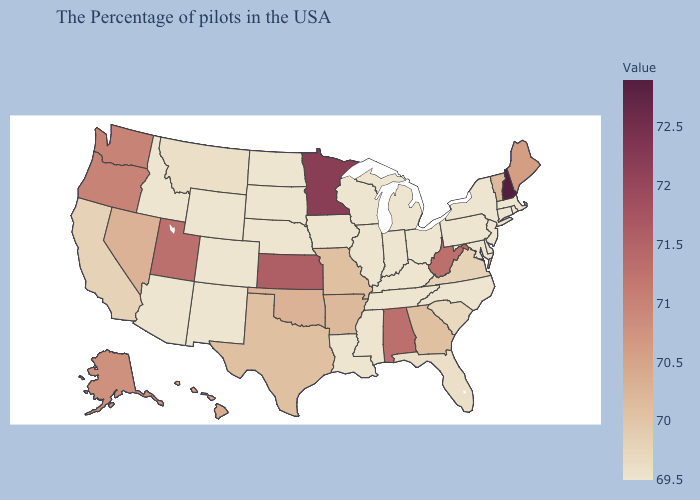Among the states that border Oregon , does Idaho have the highest value?
Concise answer only. No. Does the map have missing data?
Concise answer only. No. Which states have the highest value in the USA?
Give a very brief answer. New Hampshire. Among the states that border Ohio , which have the lowest value?
Be succinct. Pennsylvania, Michigan, Kentucky, Indiana. Does Virginia have the lowest value in the USA?
Concise answer only. No. Which states have the highest value in the USA?
Write a very short answer. New Hampshire. Which states have the lowest value in the USA?
Quick response, please. Massachusetts, Rhode Island, Connecticut, New York, New Jersey, Delaware, Maryland, Pennsylvania, North Carolina, Ohio, Michigan, Kentucky, Indiana, Tennessee, Wisconsin, Illinois, Mississippi, Louisiana, Iowa, Nebraska, South Dakota, North Dakota, Wyoming, Colorado, New Mexico, Arizona, Idaho. Does West Virginia have a higher value than Wisconsin?
Answer briefly. Yes. Which states hav the highest value in the West?
Quick response, please. Utah. 